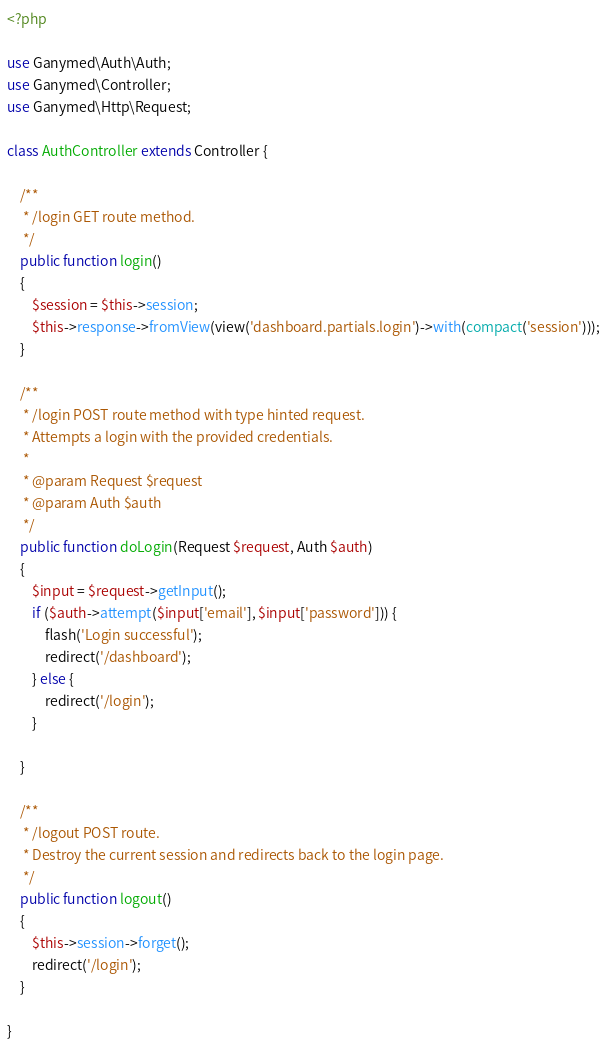Convert code to text. <code><loc_0><loc_0><loc_500><loc_500><_PHP_><?php

use Ganymed\Auth\Auth;
use Ganymed\Controller;
use Ganymed\Http\Request;

class AuthController extends Controller {

    /**
     * /login GET route method.
     */
    public function login()
    {
        $session = $this->session;
        $this->response->fromView(view('dashboard.partials.login')->with(compact('session')));
    }

    /**
     * /login POST route method with type hinted request.
     * Attempts a login with the provided credentials.
     *
     * @param Request $request
     * @param Auth $auth
     */
    public function doLogin(Request $request, Auth $auth)
    {
        $input = $request->getInput();
        if ($auth->attempt($input['email'], $input['password'])) {
            flash('Login successful');
            redirect('/dashboard');
        } else {
            redirect('/login');
        }

    }

    /**
     * /logout POST route.
     * Destroy the current session and redirects back to the login page.
     */
    public function logout()
    {
        $this->session->forget();
        redirect('/login');
    }

}</code> 